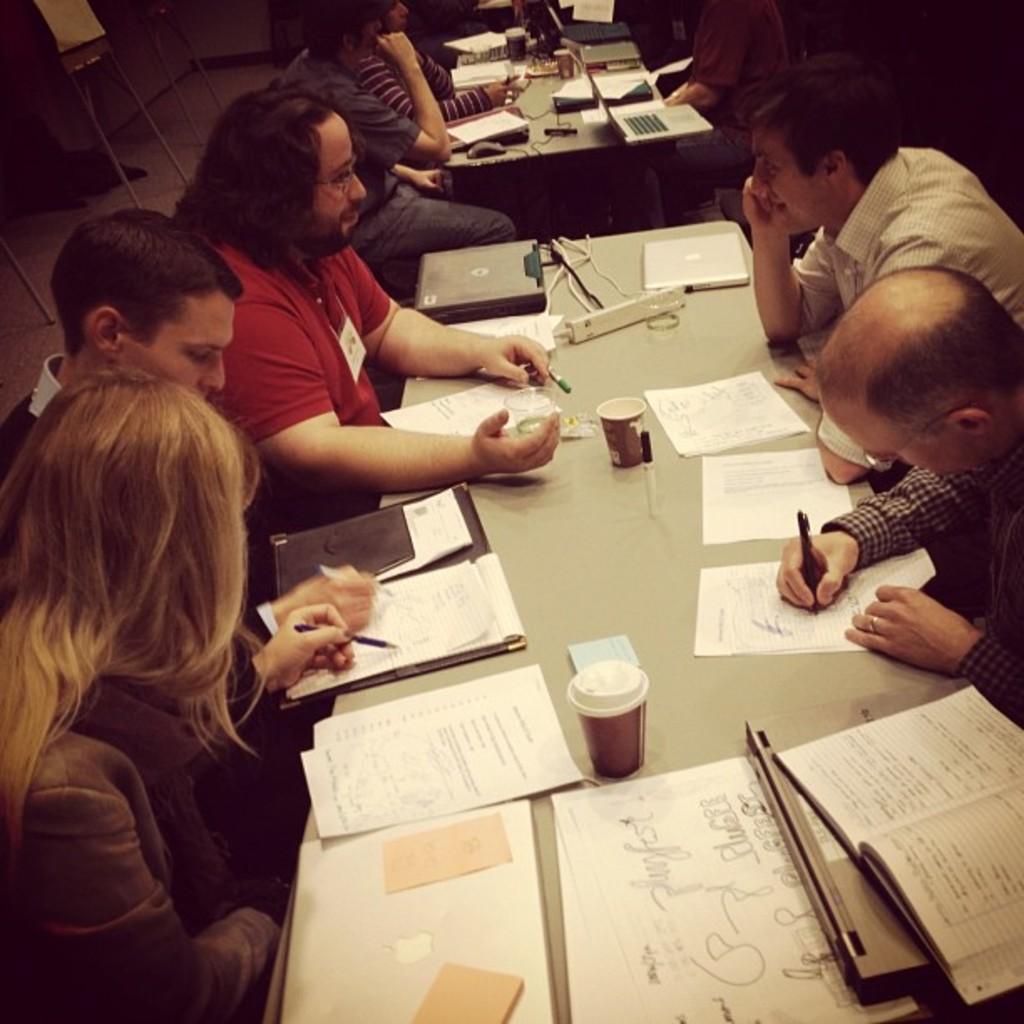Describe this image in one or two sentences. In the image there are many people sat on either sides of table reading and writing. 